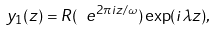Convert formula to latex. <formula><loc_0><loc_0><loc_500><loc_500>y _ { 1 } ( z ) = R ( \ e ^ { 2 \pi i z / \omega } ) \exp ( i \lambda z ) ,</formula> 